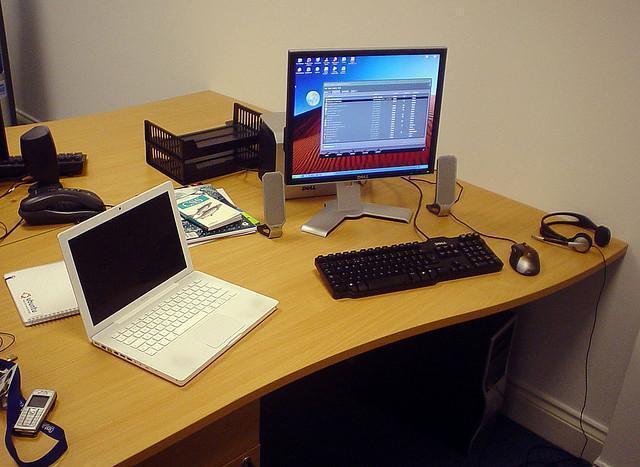What are the two standing rectangular devices?
From the following four choices, select the correct answer to address the question.
Options: Microphone, speakers, power supply, phone. Speakers. 